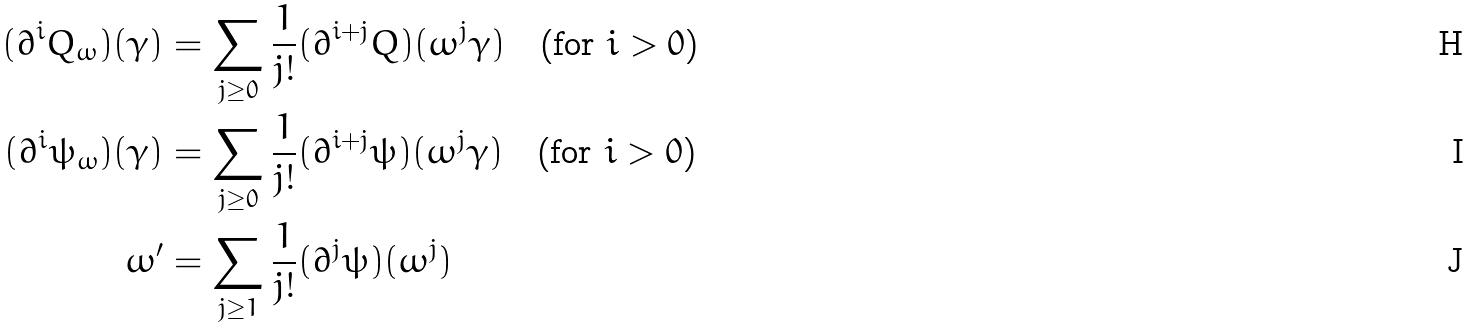Convert formula to latex. <formula><loc_0><loc_0><loc_500><loc_500>( \partial ^ { i } Q _ { \omega } ) ( \gamma ) & = \sum _ { j \geq 0 } \frac { 1 } { j ! } ( \partial ^ { i + j } Q ) ( \omega ^ { j } \gamma ) \quad \text {(for $i>0$)} \\ ( \partial ^ { i } \psi _ { \omega } ) ( \gamma ) & = \sum _ { j \geq 0 } \frac { 1 } { j ! } ( \partial ^ { i + j } \psi ) ( \omega ^ { j } \gamma ) \quad \text {(for $i>0$)} \\ \omega ^ { \prime } & = \sum _ { j \geq 1 } \frac { 1 } { j ! } ( \partial ^ { j } \psi ) ( \omega ^ { j } )</formula> 